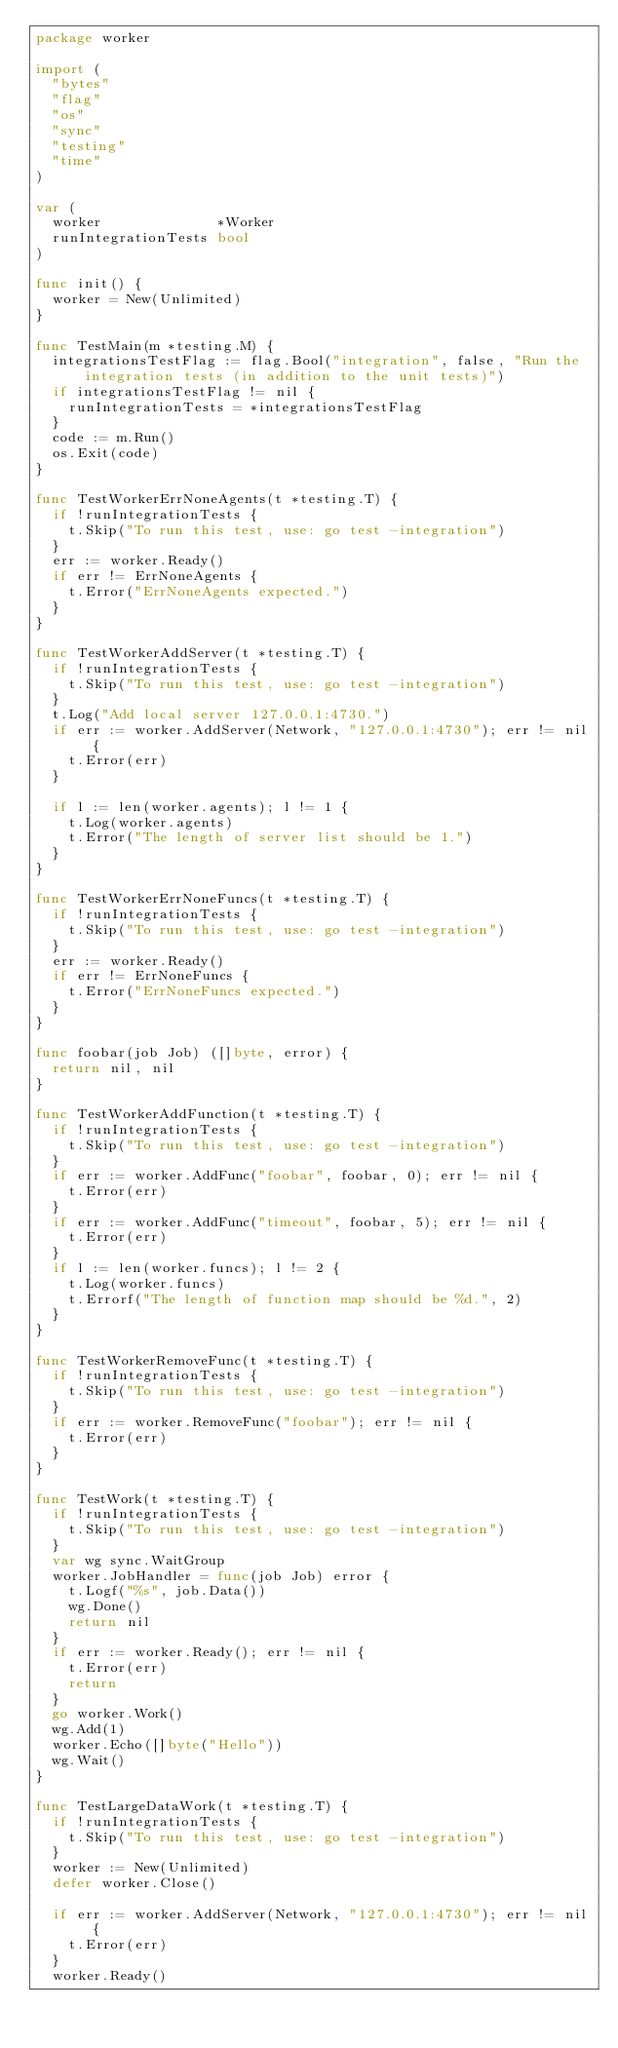<code> <loc_0><loc_0><loc_500><loc_500><_Go_>package worker

import (
	"bytes"
	"flag"
	"os"
	"sync"
	"testing"
	"time"
)

var (
	worker              *Worker
	runIntegrationTests bool
)

func init() {
	worker = New(Unlimited)
}

func TestMain(m *testing.M) {
	integrationsTestFlag := flag.Bool("integration", false, "Run the integration tests (in addition to the unit tests)")
	if integrationsTestFlag != nil {
		runIntegrationTests = *integrationsTestFlag
	}
	code := m.Run()
	os.Exit(code)
}

func TestWorkerErrNoneAgents(t *testing.T) {
	if !runIntegrationTests {
		t.Skip("To run this test, use: go test -integration")
	}
	err := worker.Ready()
	if err != ErrNoneAgents {
		t.Error("ErrNoneAgents expected.")
	}
}

func TestWorkerAddServer(t *testing.T) {
	if !runIntegrationTests {
		t.Skip("To run this test, use: go test -integration")
	}
	t.Log("Add local server 127.0.0.1:4730.")
	if err := worker.AddServer(Network, "127.0.0.1:4730"); err != nil {
		t.Error(err)
	}

	if l := len(worker.agents); l != 1 {
		t.Log(worker.agents)
		t.Error("The length of server list should be 1.")
	}
}

func TestWorkerErrNoneFuncs(t *testing.T) {
	if !runIntegrationTests {
		t.Skip("To run this test, use: go test -integration")
	}
	err := worker.Ready()
	if err != ErrNoneFuncs {
		t.Error("ErrNoneFuncs expected.")
	}
}

func foobar(job Job) ([]byte, error) {
	return nil, nil
}

func TestWorkerAddFunction(t *testing.T) {
	if !runIntegrationTests {
		t.Skip("To run this test, use: go test -integration")
	}
	if err := worker.AddFunc("foobar", foobar, 0); err != nil {
		t.Error(err)
	}
	if err := worker.AddFunc("timeout", foobar, 5); err != nil {
		t.Error(err)
	}
	if l := len(worker.funcs); l != 2 {
		t.Log(worker.funcs)
		t.Errorf("The length of function map should be %d.", 2)
	}
}

func TestWorkerRemoveFunc(t *testing.T) {
	if !runIntegrationTests {
		t.Skip("To run this test, use: go test -integration")
	}
	if err := worker.RemoveFunc("foobar"); err != nil {
		t.Error(err)
	}
}

func TestWork(t *testing.T) {
	if !runIntegrationTests {
		t.Skip("To run this test, use: go test -integration")
	}
	var wg sync.WaitGroup
	worker.JobHandler = func(job Job) error {
		t.Logf("%s", job.Data())
		wg.Done()
		return nil
	}
	if err := worker.Ready(); err != nil {
		t.Error(err)
		return
	}
	go worker.Work()
	wg.Add(1)
	worker.Echo([]byte("Hello"))
	wg.Wait()
}

func TestLargeDataWork(t *testing.T) {
	if !runIntegrationTests {
		t.Skip("To run this test, use: go test -integration")
	}
	worker := New(Unlimited)
	defer worker.Close()

	if err := worker.AddServer(Network, "127.0.0.1:4730"); err != nil {
		t.Error(err)
	}
	worker.Ready()
</code> 